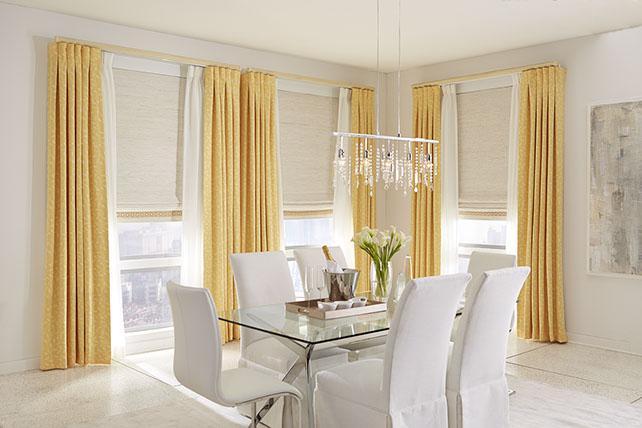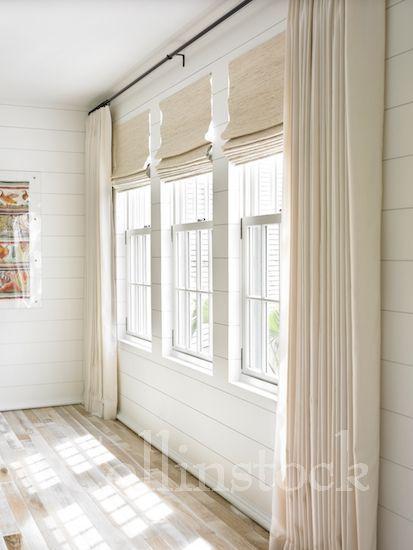The first image is the image on the left, the second image is the image on the right. For the images shown, is this caption "There are three partially open shades in the right image." true? Answer yes or no. Yes. The first image is the image on the left, the second image is the image on the right. For the images shown, is this caption "An image shows a chandelier over a table and chairs in front of a corner with a total of three tall windows hung with solid-colored drapes in front of shades pulled half-way down." true? Answer yes or no. Yes. 